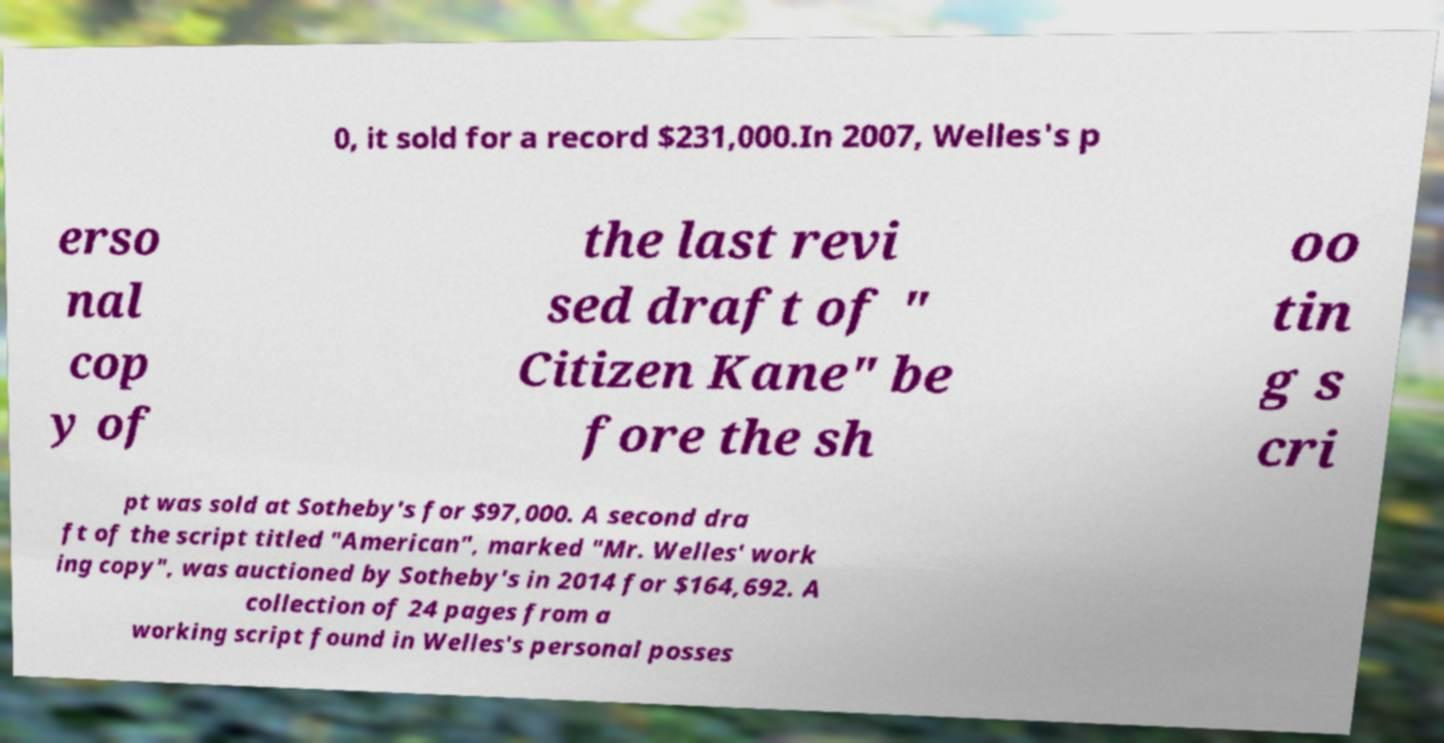What messages or text are displayed in this image? I need them in a readable, typed format. 0, it sold for a record $231,000.In 2007, Welles's p erso nal cop y of the last revi sed draft of " Citizen Kane" be fore the sh oo tin g s cri pt was sold at Sotheby's for $97,000. A second dra ft of the script titled "American", marked "Mr. Welles' work ing copy", was auctioned by Sotheby's in 2014 for $164,692. A collection of 24 pages from a working script found in Welles's personal posses 